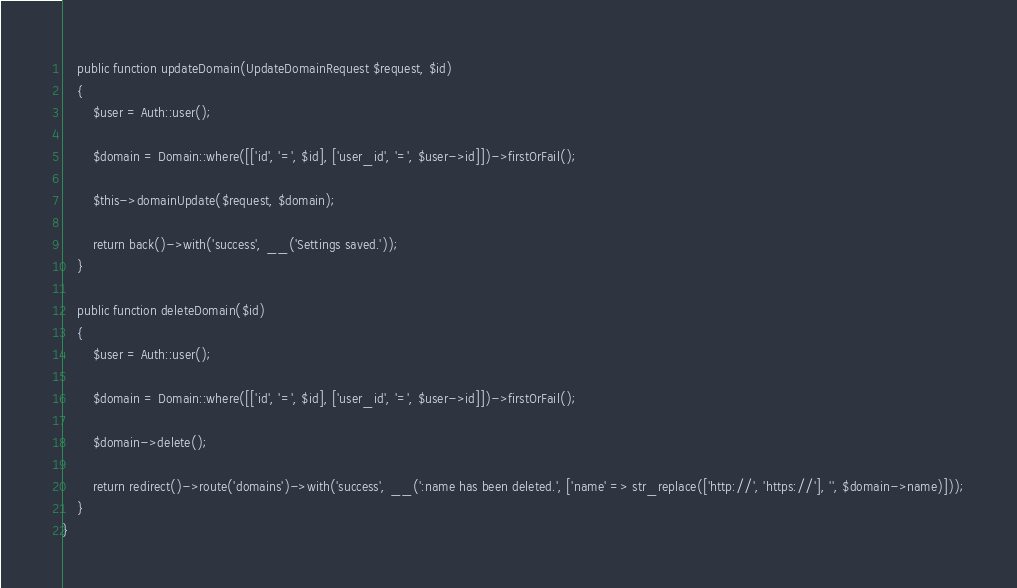Convert code to text. <code><loc_0><loc_0><loc_500><loc_500><_PHP_>    public function updateDomain(UpdateDomainRequest $request, $id)
    {
        $user = Auth::user();

        $domain = Domain::where([['id', '=', $id], ['user_id', '=', $user->id]])->firstOrFail();

        $this->domainUpdate($request, $domain);

        return back()->with('success', __('Settings saved.'));
    }

    public function deleteDomain($id)
    {
        $user = Auth::user();

        $domain = Domain::where([['id', '=', $id], ['user_id', '=', $user->id]])->firstOrFail();

        $domain->delete();

        return redirect()->route('domains')->with('success', __(':name has been deleted.', ['name' => str_replace(['http://', 'https://'], '', $domain->name)]));
    }
}
</code> 